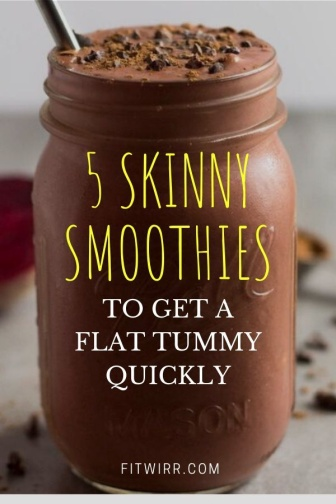How does the presentation of the smoothie contribute to its appeal? The presentation of the smoothie in the image is quite thoughtful. The mason jar offers a rustic, yet chic appeal which is popular in modern food aesthetics. The use of a metal straw not only adds to the charm but also conveys an eco-conscious message. The choice of a clear label with bold, handwritten-style text draws attention directly to the health claim, making it a focal point for anyone interested in wellness. Lastly, the casual sprinkle of chocolate chips and raspberry presents an unpretentious, yet deliberate garnishing choice that suggests a balance between indulgence and health. 